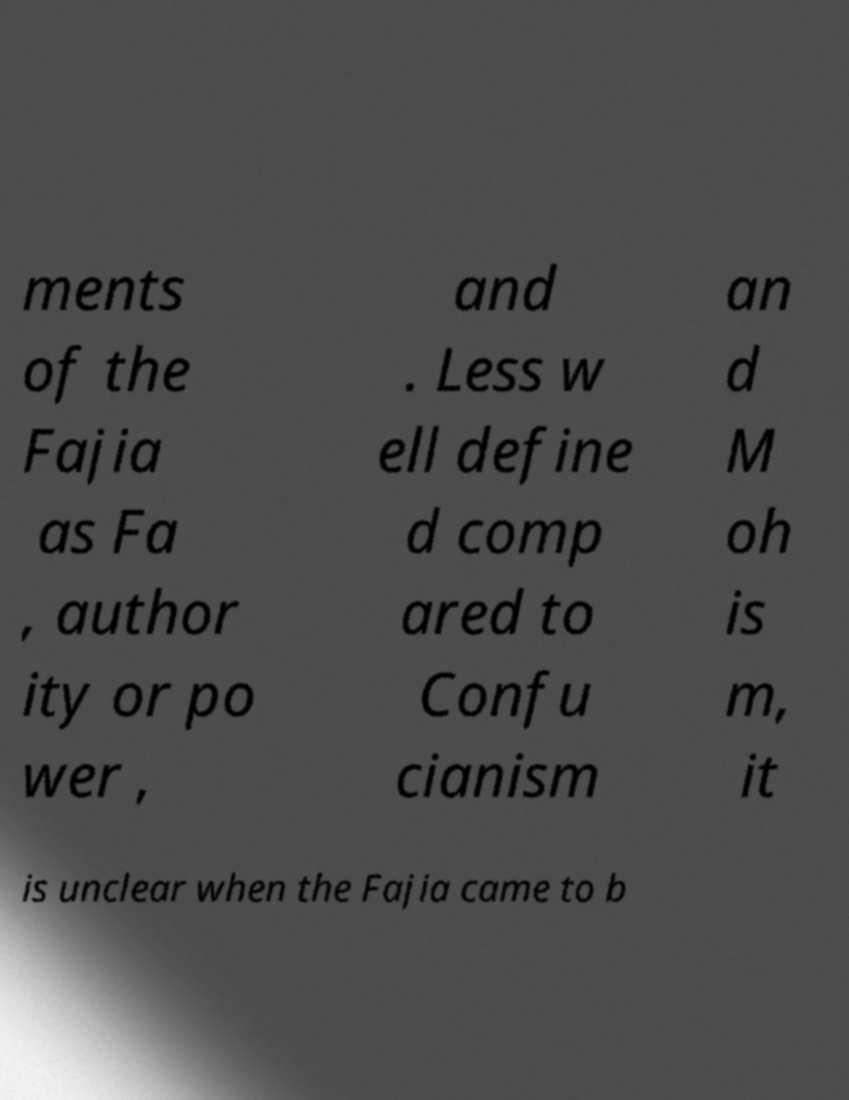There's text embedded in this image that I need extracted. Can you transcribe it verbatim? ments of the Fajia as Fa , author ity or po wer , and . Less w ell define d comp ared to Confu cianism an d M oh is m, it is unclear when the Fajia came to b 